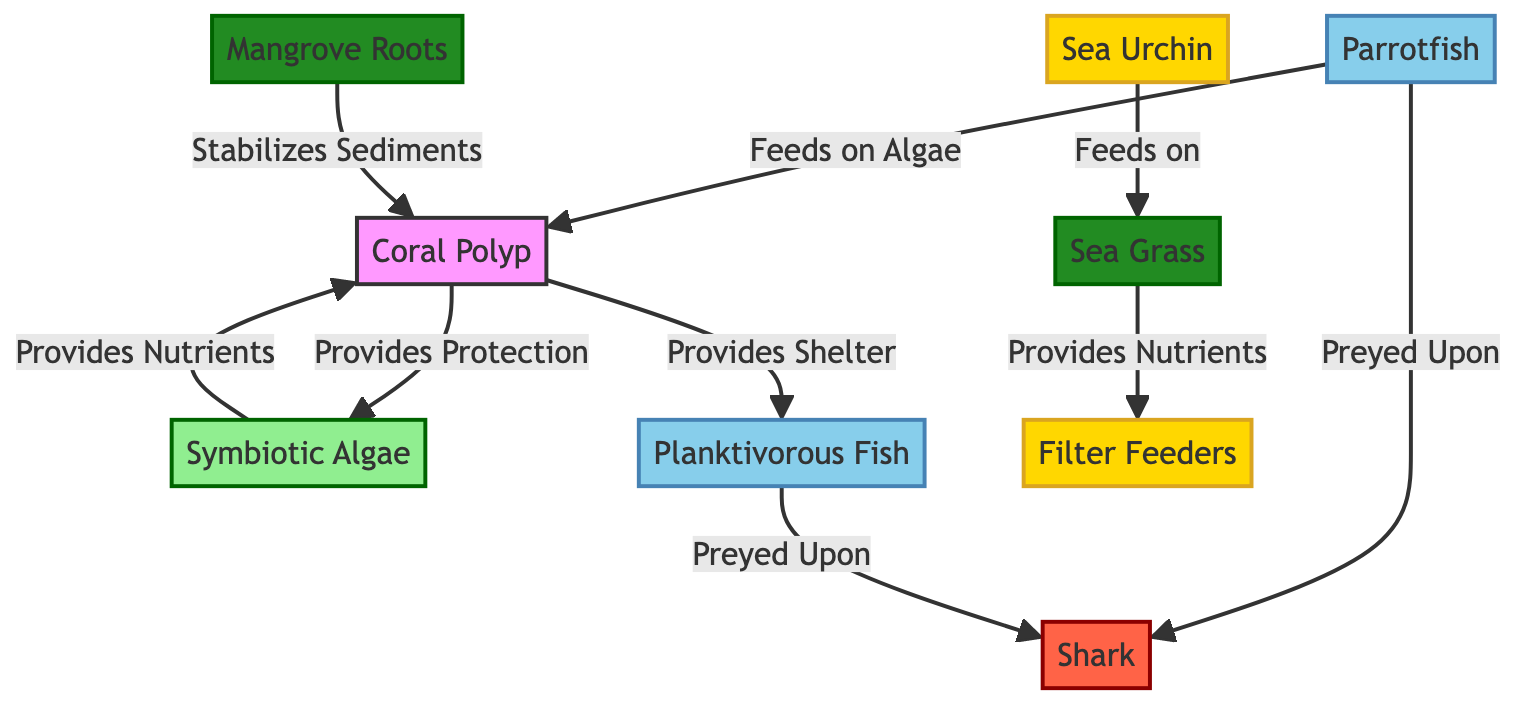What is the relationship between coral polyp and symbiotic algae? According to the diagram, coral polyp provides protection to symbiotic algae, while symbiotic algae provides nutrients to coral polyp. This reciprocal relationship is shown by the arrows connecting these two nodes.
Answer: Provides Protection / Provides Nutrients How many different types of plants are represented in the diagram? The diagram shows two types of plants: Mangrove Roots and Sea Grass. Both types are illustrated distinctly and named in the diagram.
Answer: 2 Which organism feeds on algae according to the diagram? The diagram indicates that Parrotfish feeds on algae, which is explicitly connected to coral polyp, shown as feeding on it.
Answer: Parrotfish What role does the apex predator play in the ecosystem of the coral reef? Apex predator, depicted as Shark, preys upon both Parrotfish and Planktivorous Fish as indicated by their relationships in the diagram, establishing the predator-prey dynamics.
Answer: Prey upon What provides shelter to planktivorous fish? The diagram directly states that coral polyp provides shelter to planktivorous fish as indicated by the arrow pointing from coral polyp to planktivorous fish.
Answer: Coral Polyp Which organism is shown to feed on Sea Grass? Sea Urchin is indicated in the diagram as feeding on Sea Grass, as illustrated by their directional relationship.
Answer: Sea Urchin How many total interactions (arrows) are represented in the diagram? By counting all the directed arrows connecting the different organisms and plants, there are a total of 8 interactions displayed, each showing various ecological relationships.
Answer: 8 What stabilizes sediments in the coral reef ecosystem? Mangrove Roots are depicted in the diagram as the entity that stabilizes sediments, linking directly to the coral polyp.
Answer: Mangrove Roots 